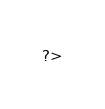Convert code to text. <code><loc_0><loc_0><loc_500><loc_500><_PHP_>?>
</code> 